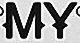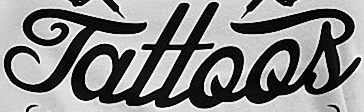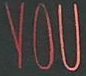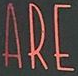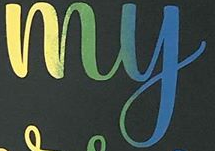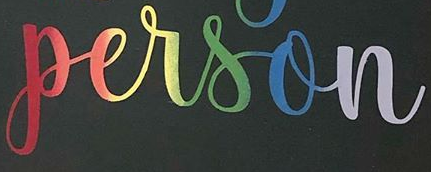Read the text from these images in sequence, separated by a semicolon. MY; Tattoos; YOU; ARE; my; person 